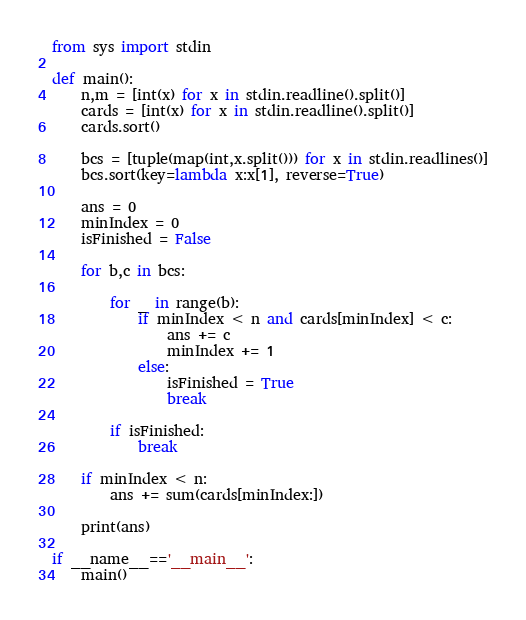<code> <loc_0><loc_0><loc_500><loc_500><_Python_>from sys import stdin
 
def main():
    n,m = [int(x) for x in stdin.readline().split()]
    cards = [int(x) for x in stdin.readline().split()]
    cards.sort()
 
    bcs = [tuple(map(int,x.split())) for x in stdin.readlines()]
    bcs.sort(key=lambda x:x[1], reverse=True)
 
    ans = 0
    minIndex = 0
    isFinished = False
 
    for b,c in bcs:
 
        for _ in range(b):
            if minIndex < n and cards[minIndex] < c:
                ans += c
                minIndex += 1
            else:
                isFinished = True
                break
        
        if isFinished:
            break
 
    if minIndex < n:
        ans += sum(cards[minIndex:])
 
    print(ans)
    
if __name__=='__main__':
    main()</code> 